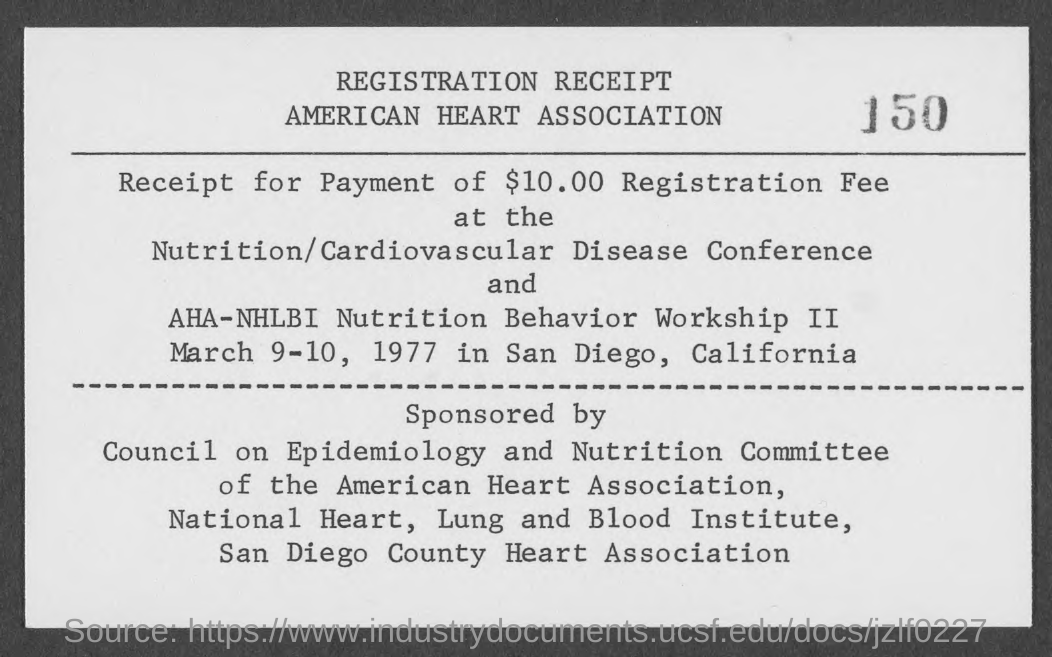Specify some key components in this picture. The program will be held in San Diego, California. This is a registration receipt, which is a type of document that serves as proof of registration or purchase. The registration fee received was $10.00. The Nutrition/Cardiovascular Disease Conference is about [insert description of conference]. The program will take place on March 9-10, 1977. 